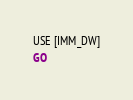<code> <loc_0><loc_0><loc_500><loc_500><_SQL_>USE [IMM_DW]
GO
</code> 